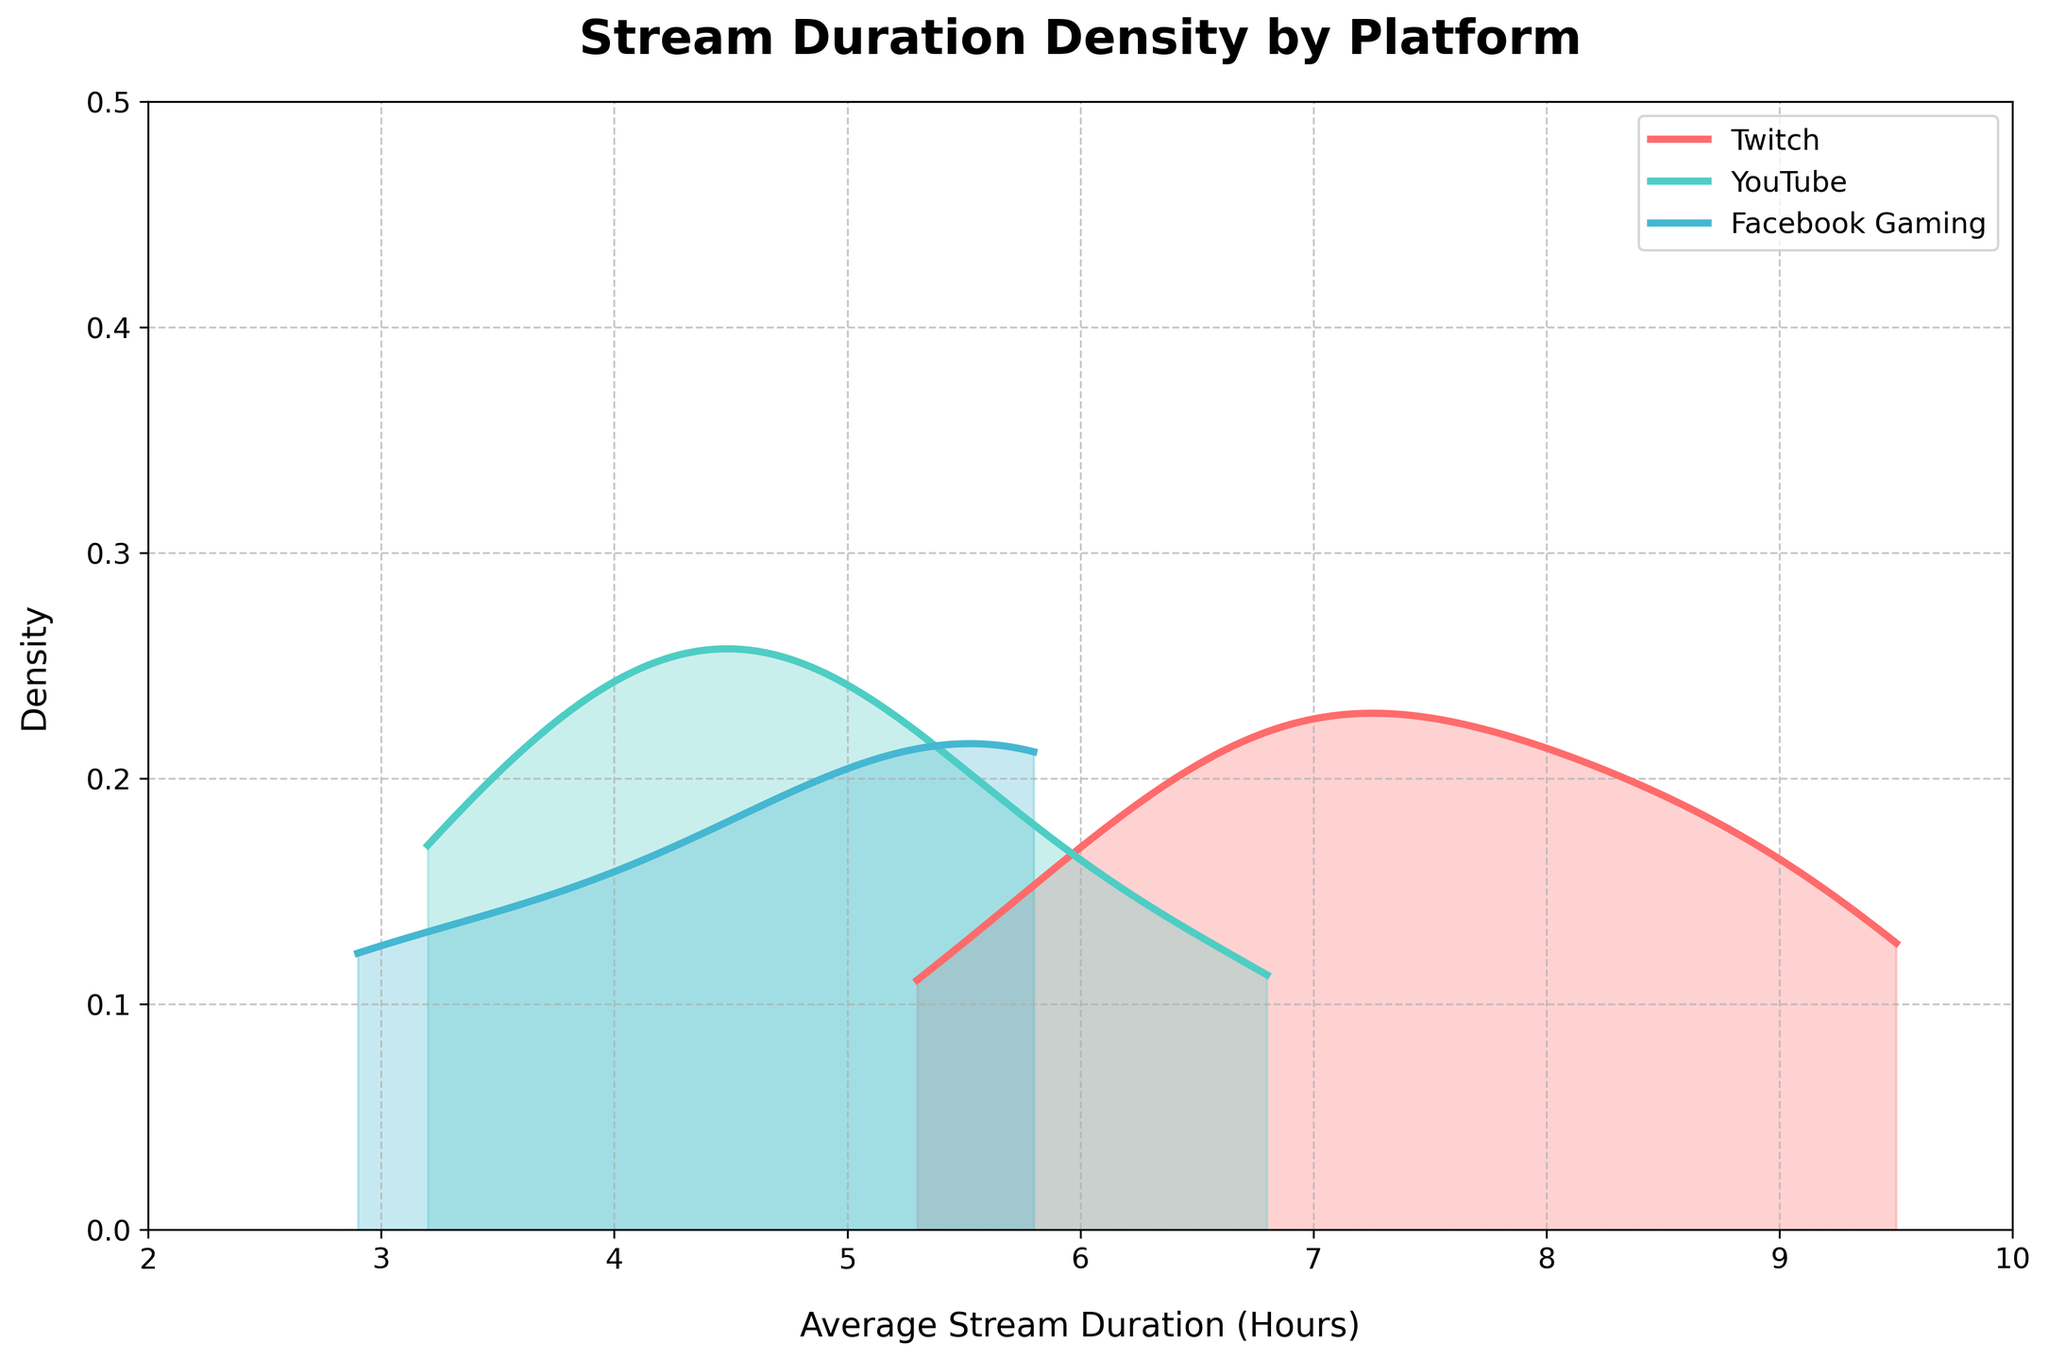What is the title of the figure? The title of the figure is displayed at the top of the plot and is generally used to describe the main content or purpose of the plot. In this case, the title is "Stream Duration Density by Platform."
Answer: Stream Duration Density by Platform What are the three platforms represented in the plot? The labels on the legend in the upper right corner of the plot identify the represented platforms. They are Twitch, YouTube, and Facebook Gaming.
Answer: Twitch, YouTube, Facebook Gaming Which platform has the highest peak density for stream duration? The highest peak density is indicated by the tallest curve in the plot. By observing the curves, the Twitch platform has the highest peak density.
Answer: Twitch What is the approximate peak density value of the Twitch platform? The peak density value for Twitch can be inferred by looking at the highest point of the Twitch curve and referencing the corresponding y-axis value. It appears to be slightly below 0.35.
Answer: ~0.35 How does the shape of the density curve for Facebook Gaming compare to YouTube? Comparing the shapes of the curves for Facebook Gaming and YouTube, Facebook Gaming has a broader, flatter curve while YouTube's curve is narrower and more peaked.
Answer: Facebook Gaming is broader and flatter; YouTube is narrower and more peaked What is the approximate range of stream duration hours covered in the plot? The x-axis represents the stream duration hours. The plot covers the range from 2 to 10 hours.
Answer: 2 to 10 hours What does the area under each density curve represent? The area under a density curve represents the probability distribution of stream durations for that platform. Each entire area sums to 1, indicating the total probability.
Answer: Probability distribution of stream durations At approximately which stream duration hour do all the platforms' curves overlap? Observe where all three density curves intersect on the x-axis. All curves overlap at around 5 to 6 hours.
Answer: ~5 to 6 hours Which platform has the widest range of stream durations? To determine the widest range, compare the spread of each platform's density curve on the x-axis. Twitch seems to have the widest range, spanning from about 5 to 9.5 hours.
Answer: Twitch 